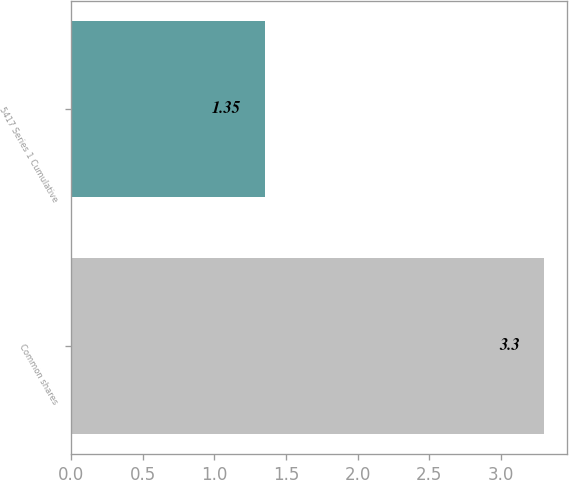Convert chart. <chart><loc_0><loc_0><loc_500><loc_500><bar_chart><fcel>Common shares<fcel>5417 Series 1 Cumulative<nl><fcel>3.3<fcel>1.35<nl></chart> 